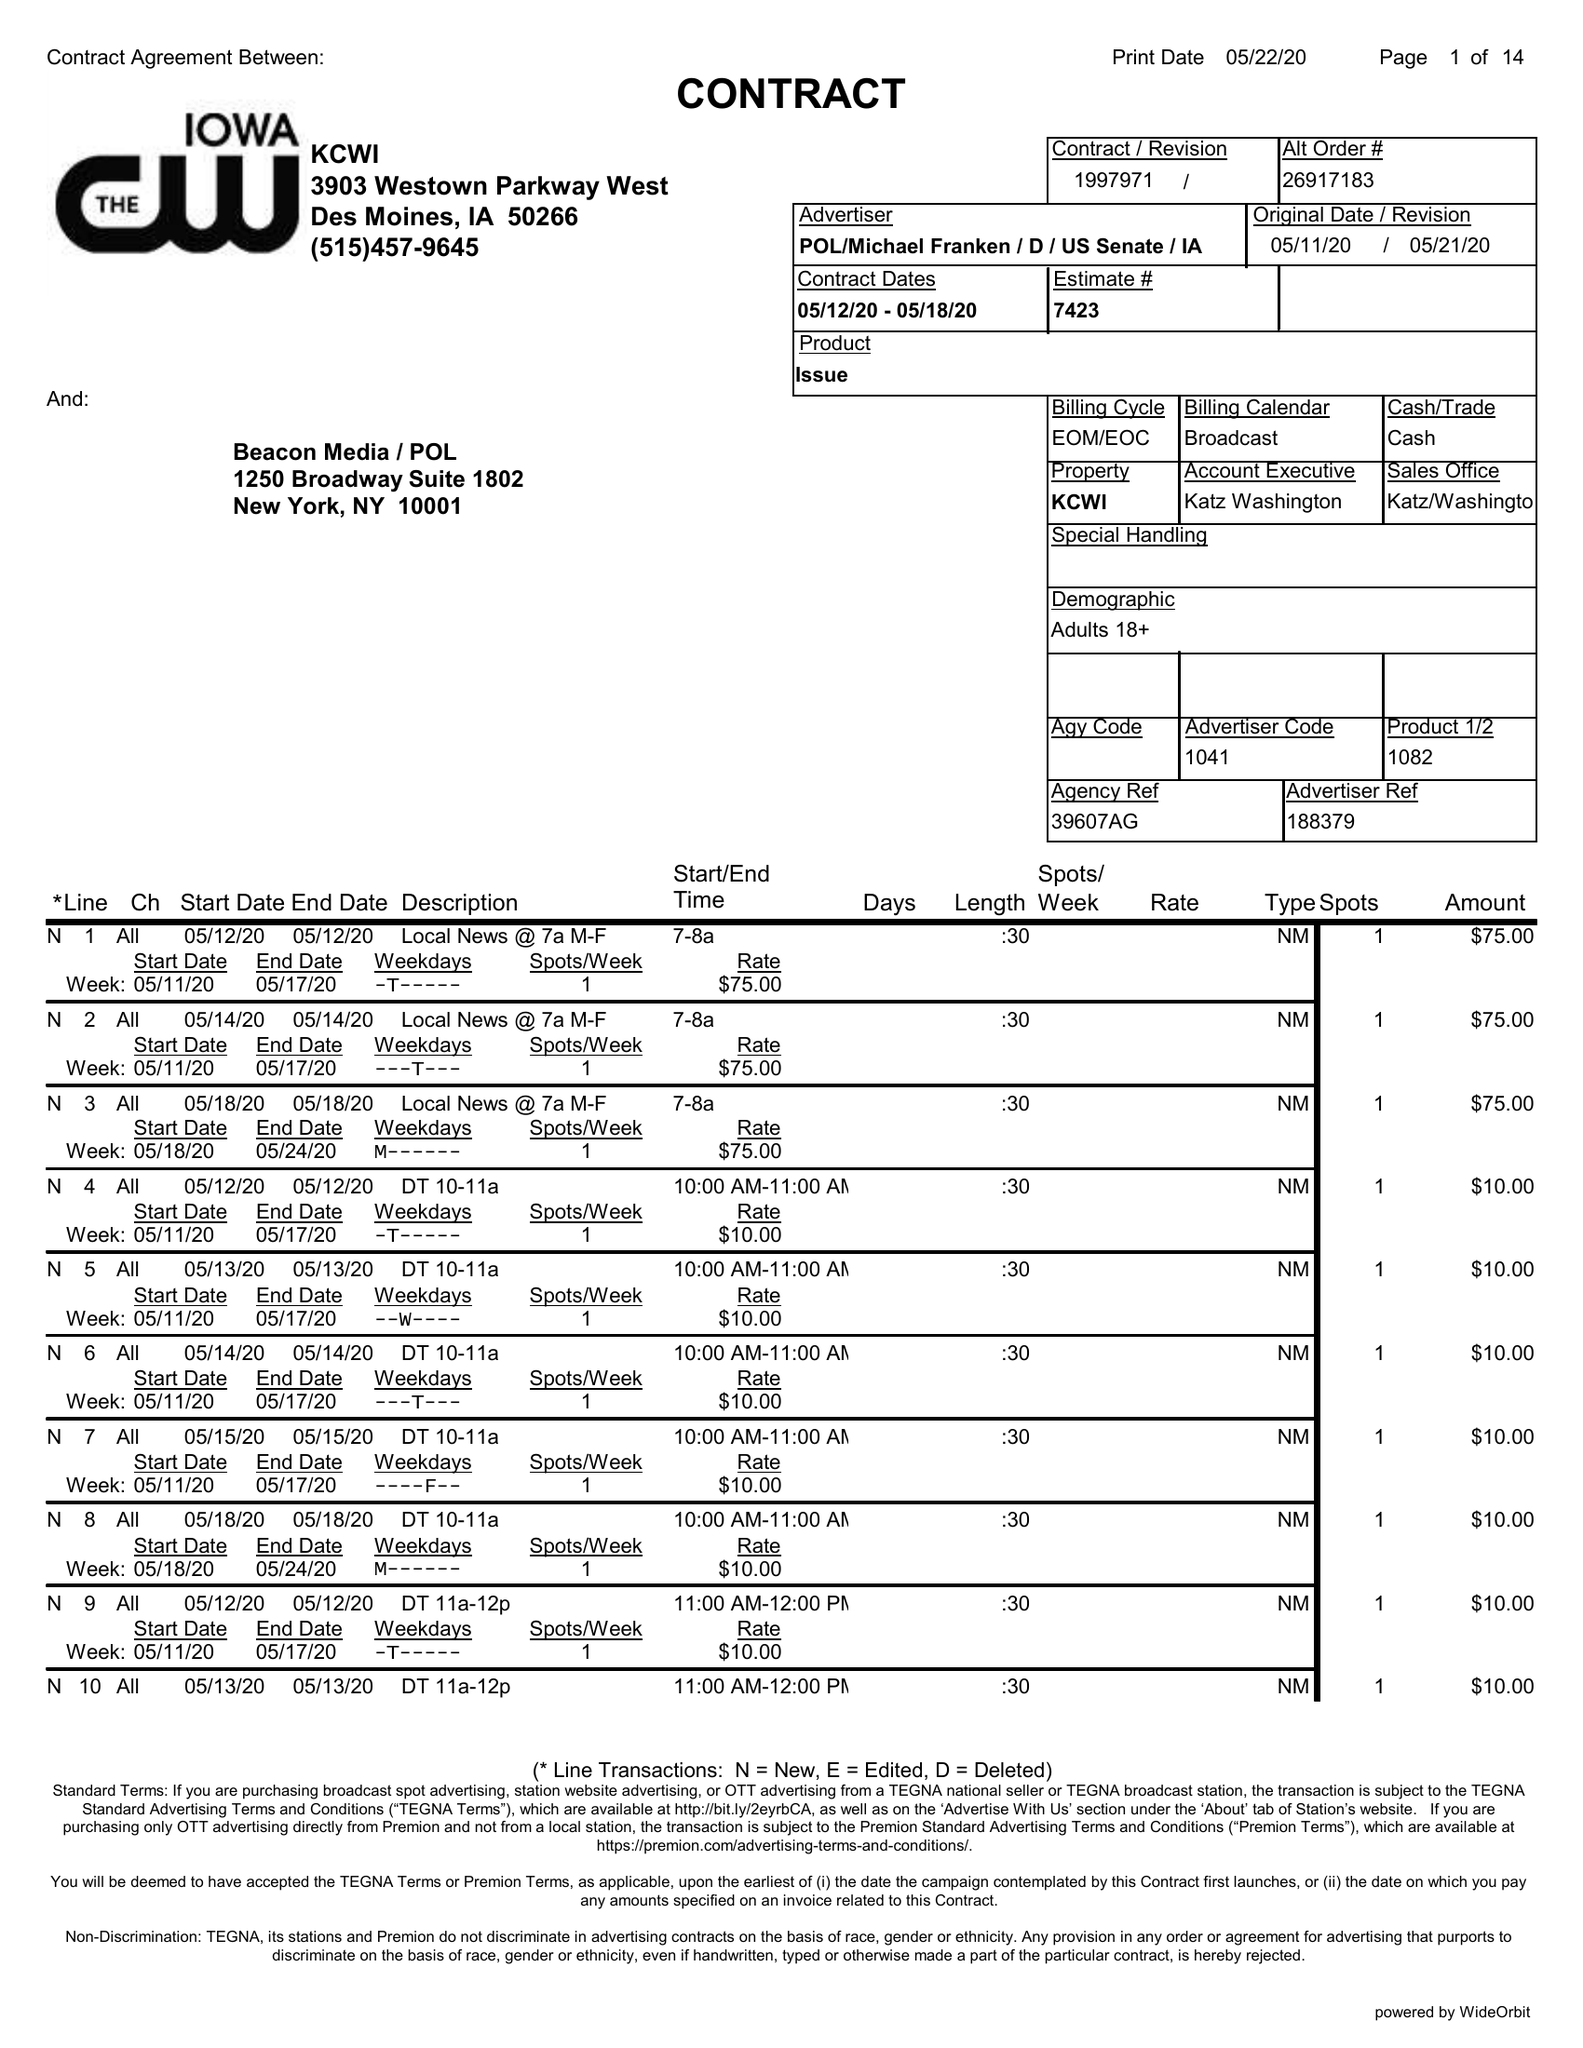What is the value for the gross_amount?
Answer the question using a single word or phrase. 1480.00 